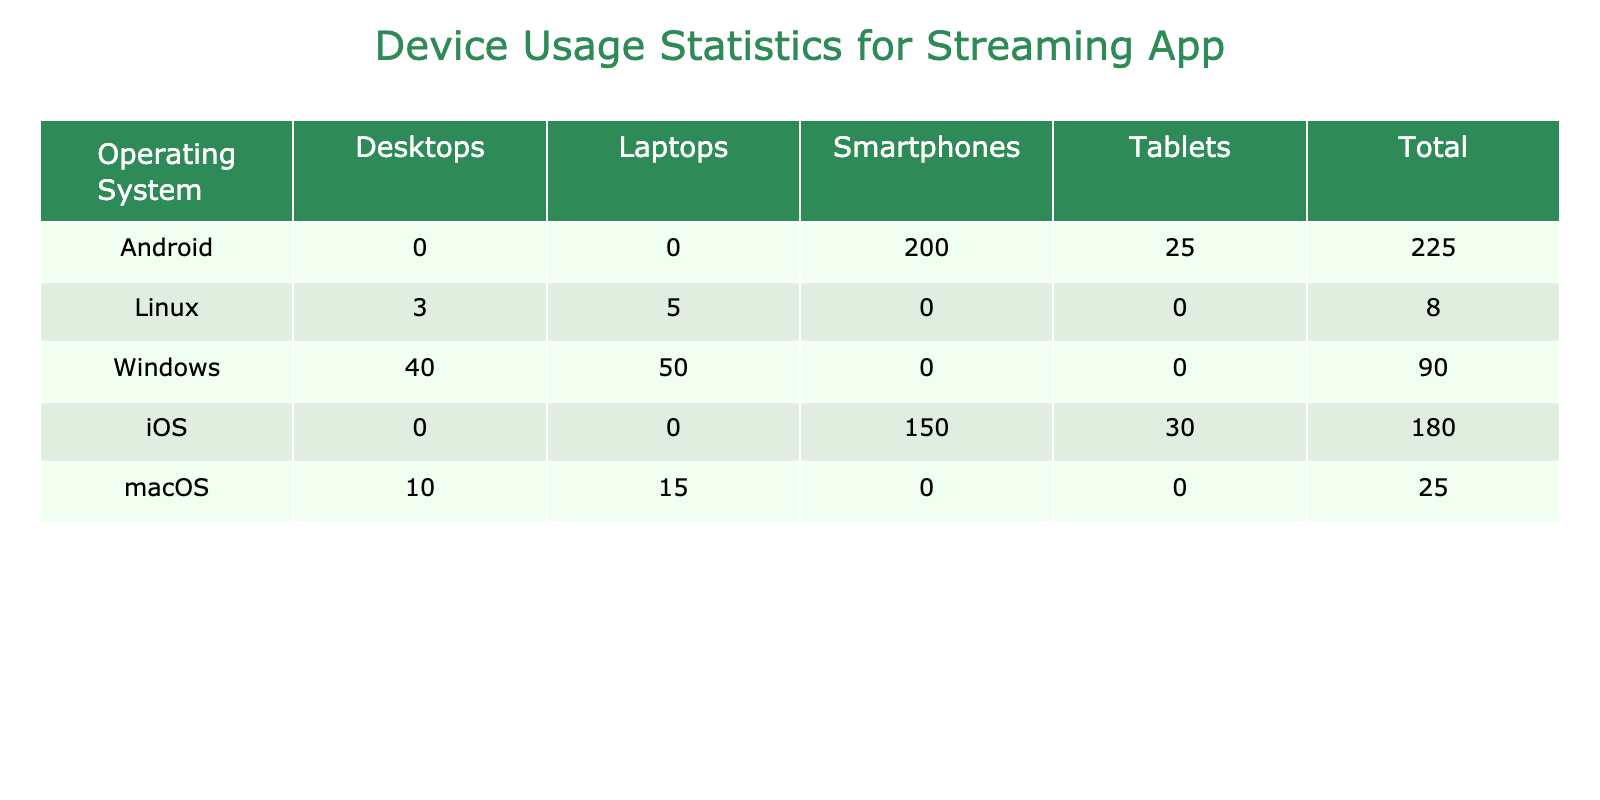What is the total number of users on iOS devices? From the table, the number of users for iOS smartphones is 150 million and for iOS tablets is 30 million. Therefore, the total is 150 + 30 = 180 million.
Answer: 180 million How many users are on Android tablets? The table shows that the number of users on Android tablets is 25 million.
Answer: 25 million Which operating system has the highest number of total users? By inspecting the total users for each operating system, Android has the highest number of users with 200 million (smartphones) + 25 million (tablets) = 225 million. iOS has 180 million, Windows has 90 million, macOS has 25 million, and Linux has 8 million. Thus, Android has the most.
Answer: Android What is the combined number of users for macOS laptops and desktops? The total users for macOS laptops is 15 million and for macOS desktops is 10 million. So, the combined total is 15 + 10 = 25 million.
Answer: 25 million Is there any operating system that has only laptop users? Looking at the data, macOS and Linux have laptop users, but both have desktop users too. Therefore, there are no operating systems with only laptop users.
Answer: No What percentage of Windows users are using laptops versus desktops? For Windows, there are 50 million laptop users and 40 million desktop users. The total is 50 + 40 = 90 million. The percentage of laptop users is (50/90) * 100 = approximately 55.56%, and for desktops, it is (40/90) * 100 = approximately 44.44%.
Answer: 55.56% laptops, 44.44% desktops If the total users were to increase by 10% across all devices, what would be the new total for Android smartphones? The current number of users for Android smartphones is 200 million. An increase of 10% means calculating 10% of 200 million, which is 20 million. Thus, the new total would be 200 + 20 = 220 million.
Answer: 220 million Which two operating systems combined have a total of less than 100 million users? The table indicates that Windows has 90 million, macOS has 25 million, and Linux has 8 million. The combined total for Windows and macOS is 90 + 25 = 115 million (greater than 100 million), while combining Windows and Linux gives 90 + 8 = 98 million (less than 100 million). So, Windows and Linux are the answer.
Answer: Windows and Linux What is the ratio of Android smartphone users to iOS tablet users? The number of Android smartphone users is 200 million and the number of iOS tablet users is 30 million. Thus, the ratio is 200:30, which simplifies to 20:3 when reduced.
Answer: 20:3 